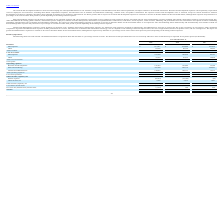From Ringcentral's financial document, What are the respective subscription revenue in 2017, 2018 and 2019? The document contains multiple relevant values: $465,254, $612,888, $817,811 (in thousands). From the document: "Subscriptions $ 817,811 $ 612,888 $ 465,254 Subscriptions $ 817,811 $ 612,888 $ 465,254 Subscriptions $ 817,811 $ 612,888 $ 465,254..." Also, What are the respective other revenue in 2017, 2018 and 2019? The document contains multiple relevant values: 38,363, 60,736, 85,047 (in thousands). From the document: "Other 85,047 60,736 38,363 Other 85,047 60,736 38,363 Other 85,047 60,736 38,363..." Also, What are the respective total revenue in 2017, 2018 and 2019? The document contains multiple relevant values: 503,617, 673,624, 902,858 (in thousands). From the document: "Total revenues 902,858 673,624 503,617 Total revenues 902,858 673,624 503,617 Total revenues 902,858 673,624 503,617..." Also, can you calculate: What is the percentage change in subscription revenue between 2017 and 2018? To answer this question, I need to perform calculations using the financial data. The calculation is: (612,888 - 465,254)/465,254 , which equals 31.73 (percentage). This is based on the information: "Subscriptions $ 817,811 $ 612,888 $ 465,254 Subscriptions $ 817,811 $ 612,888 $ 465,254..." The key data points involved are: 465,254, 612,888. Also, can you calculate: What is the percentage change in total revenue between 2017 and 2018? To answer this question, I need to perform calculations using the financial data. The calculation is: (673,624 - 503,617)/503,617 , which equals 33.76 (percentage). This is based on the information: "Total revenues 902,858 673,624 503,617 Total revenues 902,858 673,624 503,617..." The key data points involved are: 503,617, 673,624. Also, can you calculate: What is the average other cost between 2017 to 2019? To answer this question, I need to perform calculations using the financial data. The calculation is: (70,723 + 47,675 + 32,078)/3 , which equals 50158.67 (in thousands). This is based on the information: "Other 70,723 47,675 32,078 Other 70,723 47,675 32,078 Other 70,723 47,675 32,078..." The key data points involved are: 32,078, 47,675, 70,723. 